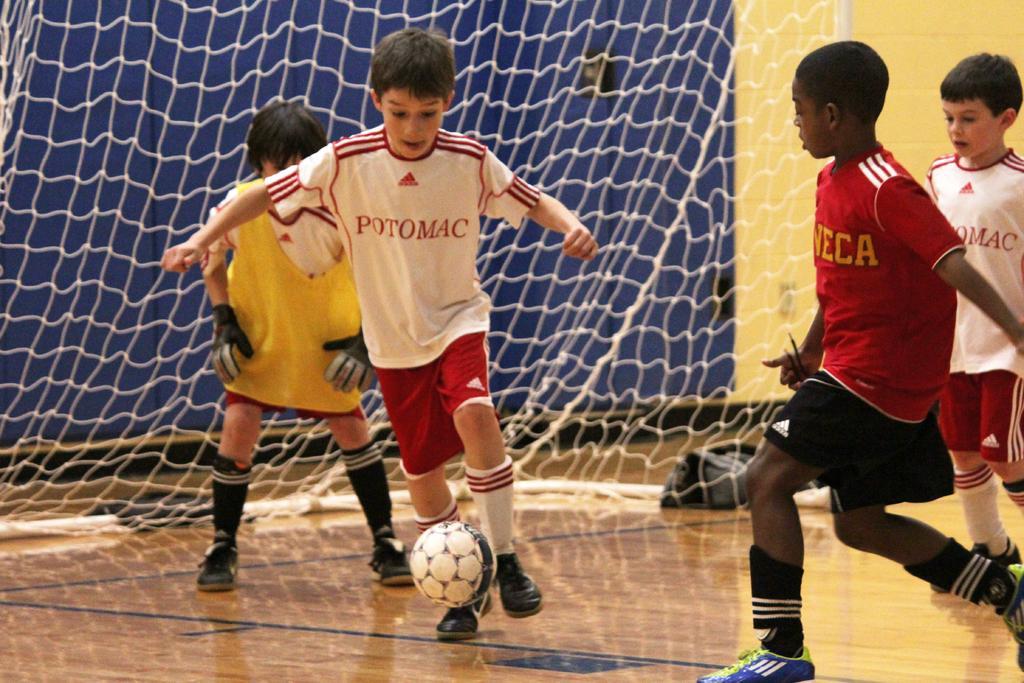How would you summarize this image in a sentence or two? In this image i can see 4 boys playing the football and in the background i can see a football net. 